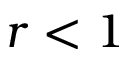Convert formula to latex. <formula><loc_0><loc_0><loc_500><loc_500>r < 1</formula> 